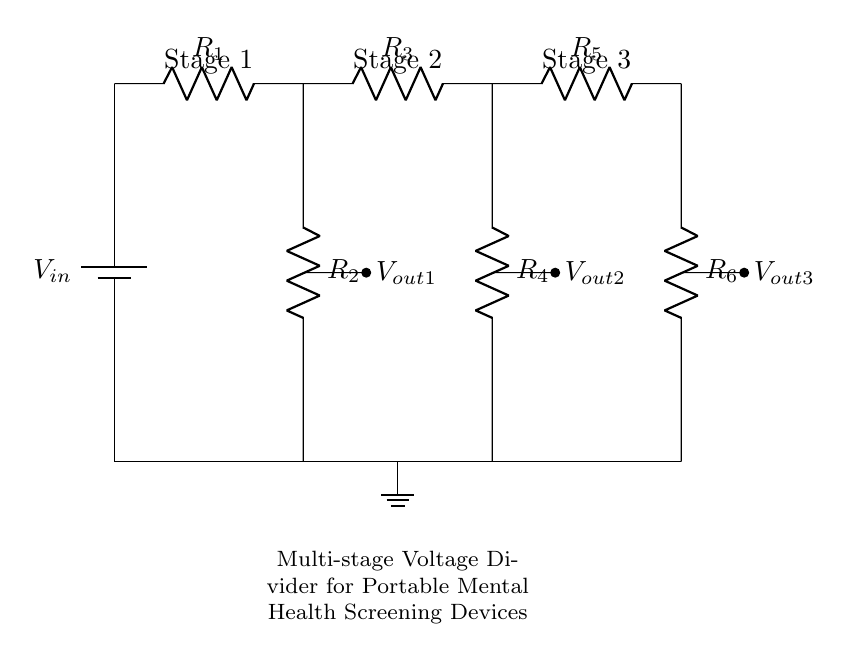What is the total number of resistors in the circuit? The diagram shows three stages of the voltage divider, each containing two resistors. Therefore, the total number of resistors is the number of stages multiplied by the number of resistors per stage, or three stages times two resistors for each stage, which results in six resistors.
Answer: Six What is the purpose of using multiple stages in this voltage divider? Multiple stages in a voltage divider allow for more precise voltage regulation. Each stage can output a different voltage for various components in the device, ensuring that each component operates within its optimal voltage range. This is particularly important for portable mental health screening devices that may use sensors and displays with different voltage requirements.
Answer: Voltage regulation What are the output voltages labeled in the circuit diagram? The circuit diagram labels the output voltages as V out1, V out2, and V out3. These outputs correspond to the voltage drops across the resistors in each stage, providing specific voltages for different components as needed in the application.
Answer: V out1, V out2, V out3 How does the input voltage affect the output voltages? The input voltage serves as the total voltage across the entire voltage divider. Each stage's output voltage is a fraction of the input voltage, determined by the resistor values according to the voltage divider formula. Thus, if the input voltage changes, the output voltages will vary based on their respective resistor ratios, affecting the components’ operational conditions accordingly.
Answer: V out depends on V in How many sections does the voltage divider circuit consist of? The circuit is divided into three distinct sections, each corresponding to a stage of the voltage divider with its own pair of resistors that tap off the voltage for the device's components. Each section reduces the voltage progressively, allowing for tailored outputs.
Answer: Three sections What is a potential risk of using resistors in a voltage divider for portable devices? A potential risk is power dissipation in the resistors, which can lead to heat generation. In portable devices, excessive heat can diminish battery life or cause component failure. Proper resistor selection and thermal management are crucial to mitigate these risks in the context of durable and reliable mental health screening devices.
Answer: Power dissipation 